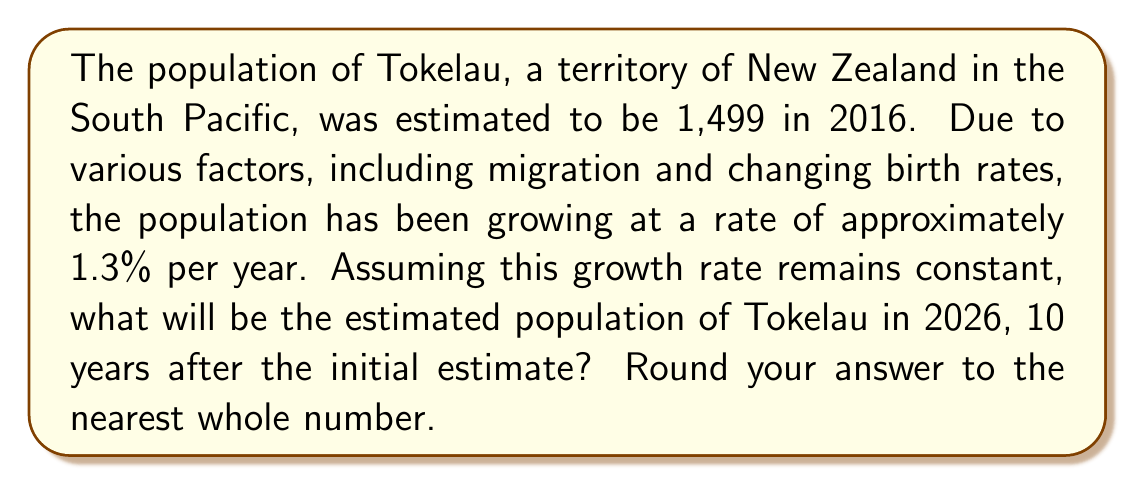Can you solve this math problem? To solve this problem, we'll use the exponential growth model:

$$P(t) = P_0 \cdot (1 + r)^t$$

Where:
$P(t)$ is the population after time $t$
$P_0$ is the initial population
$r$ is the growth rate (as a decimal)
$t$ is the time in years

Given:
$P_0 = 1,499$ (initial population in 2016)
$r = 0.013$ (1.3% growth rate)
$t = 10$ years (from 2016 to 2026)

Let's substitute these values into the formula:

$$P(10) = 1,499 \cdot (1 + 0.013)^{10}$$

Now, let's calculate step by step:

1) First, calculate $(1 + 0.013)^{10}$:
   $$(1.013)^{10} \approx 1.1384$$

2) Multiply this by the initial population:
   $$1,499 \cdot 1.1384 \approx 1,706.3616$$

3) Round to the nearest whole number:
   $$1,706$$

Therefore, the estimated population of Tokelau in 2026 will be 1,706 people.
Answer: 1,706 people 